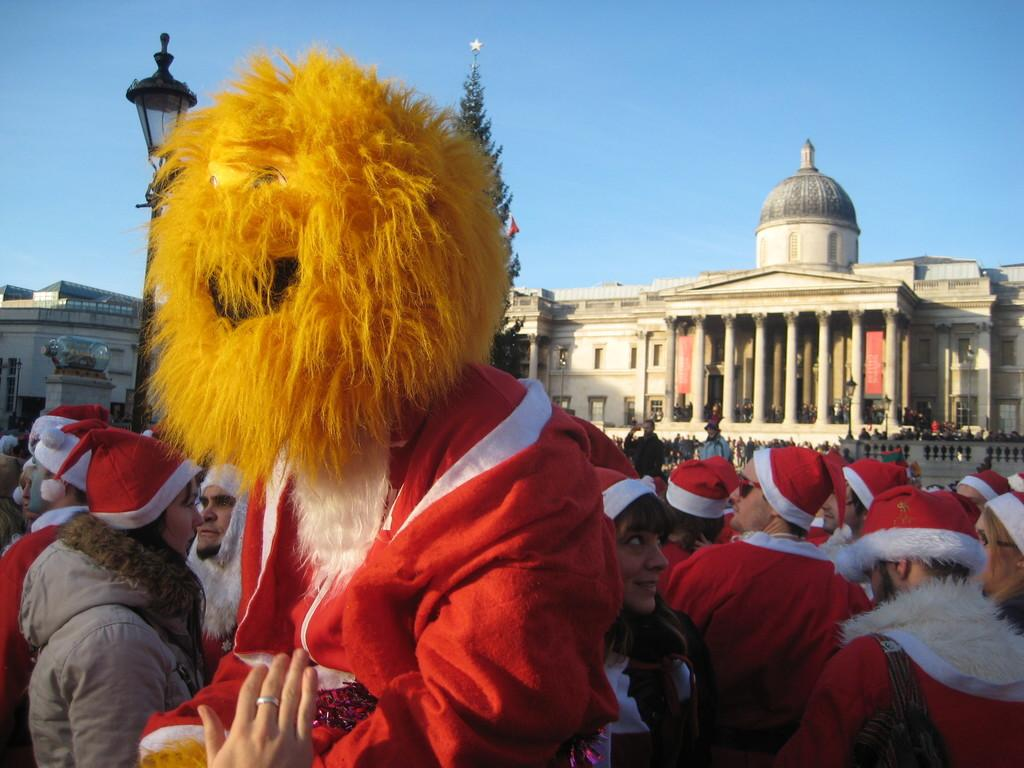What is the person in the image wearing? The person in the image is wearing a Santa costume with a tiger mask. Are there other people in the image wearing similar attire? Yes, there are other people wearing Santa costumes in the image. What is the setting of the image? The people are standing before a building. What type of jam is being spread on the fifth person's costume in the image? There is no jam present in the image, and there is no mention of a fifth person. 